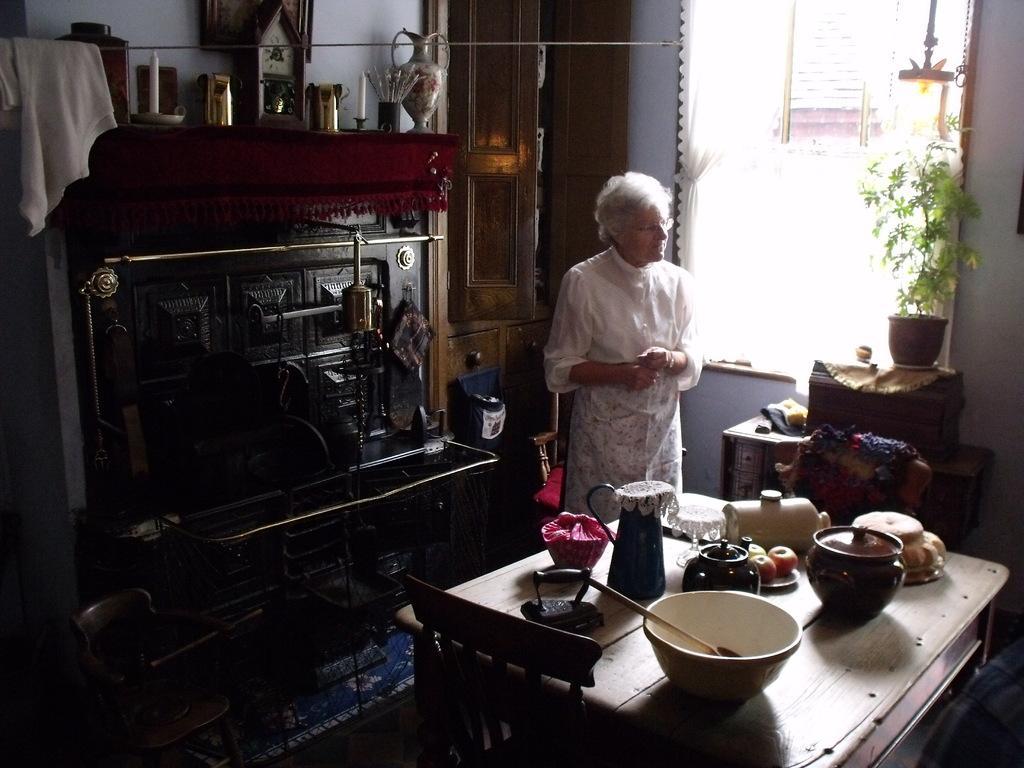Please provide a concise description of this image. In this image I can see a woman standing. This is a table. On this table there is a big bowl,jar,jug,plate with fruits and some other objects on it. This is a chair. This is another wooden object on top this there is a candle,clock,flower vase and some other objects placed on it. This is a door which is opened. This is a window with white curtains. This is a house plant which is placed on the another table. 